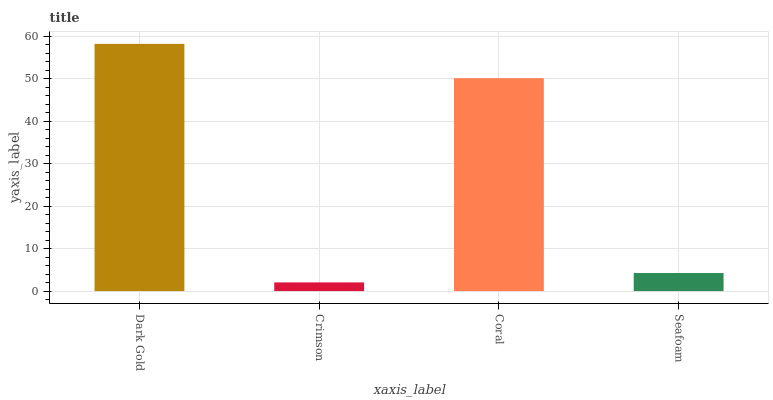Is Crimson the minimum?
Answer yes or no. Yes. Is Dark Gold the maximum?
Answer yes or no. Yes. Is Coral the minimum?
Answer yes or no. No. Is Coral the maximum?
Answer yes or no. No. Is Coral greater than Crimson?
Answer yes or no. Yes. Is Crimson less than Coral?
Answer yes or no. Yes. Is Crimson greater than Coral?
Answer yes or no. No. Is Coral less than Crimson?
Answer yes or no. No. Is Coral the high median?
Answer yes or no. Yes. Is Seafoam the low median?
Answer yes or no. Yes. Is Crimson the high median?
Answer yes or no. No. Is Crimson the low median?
Answer yes or no. No. 